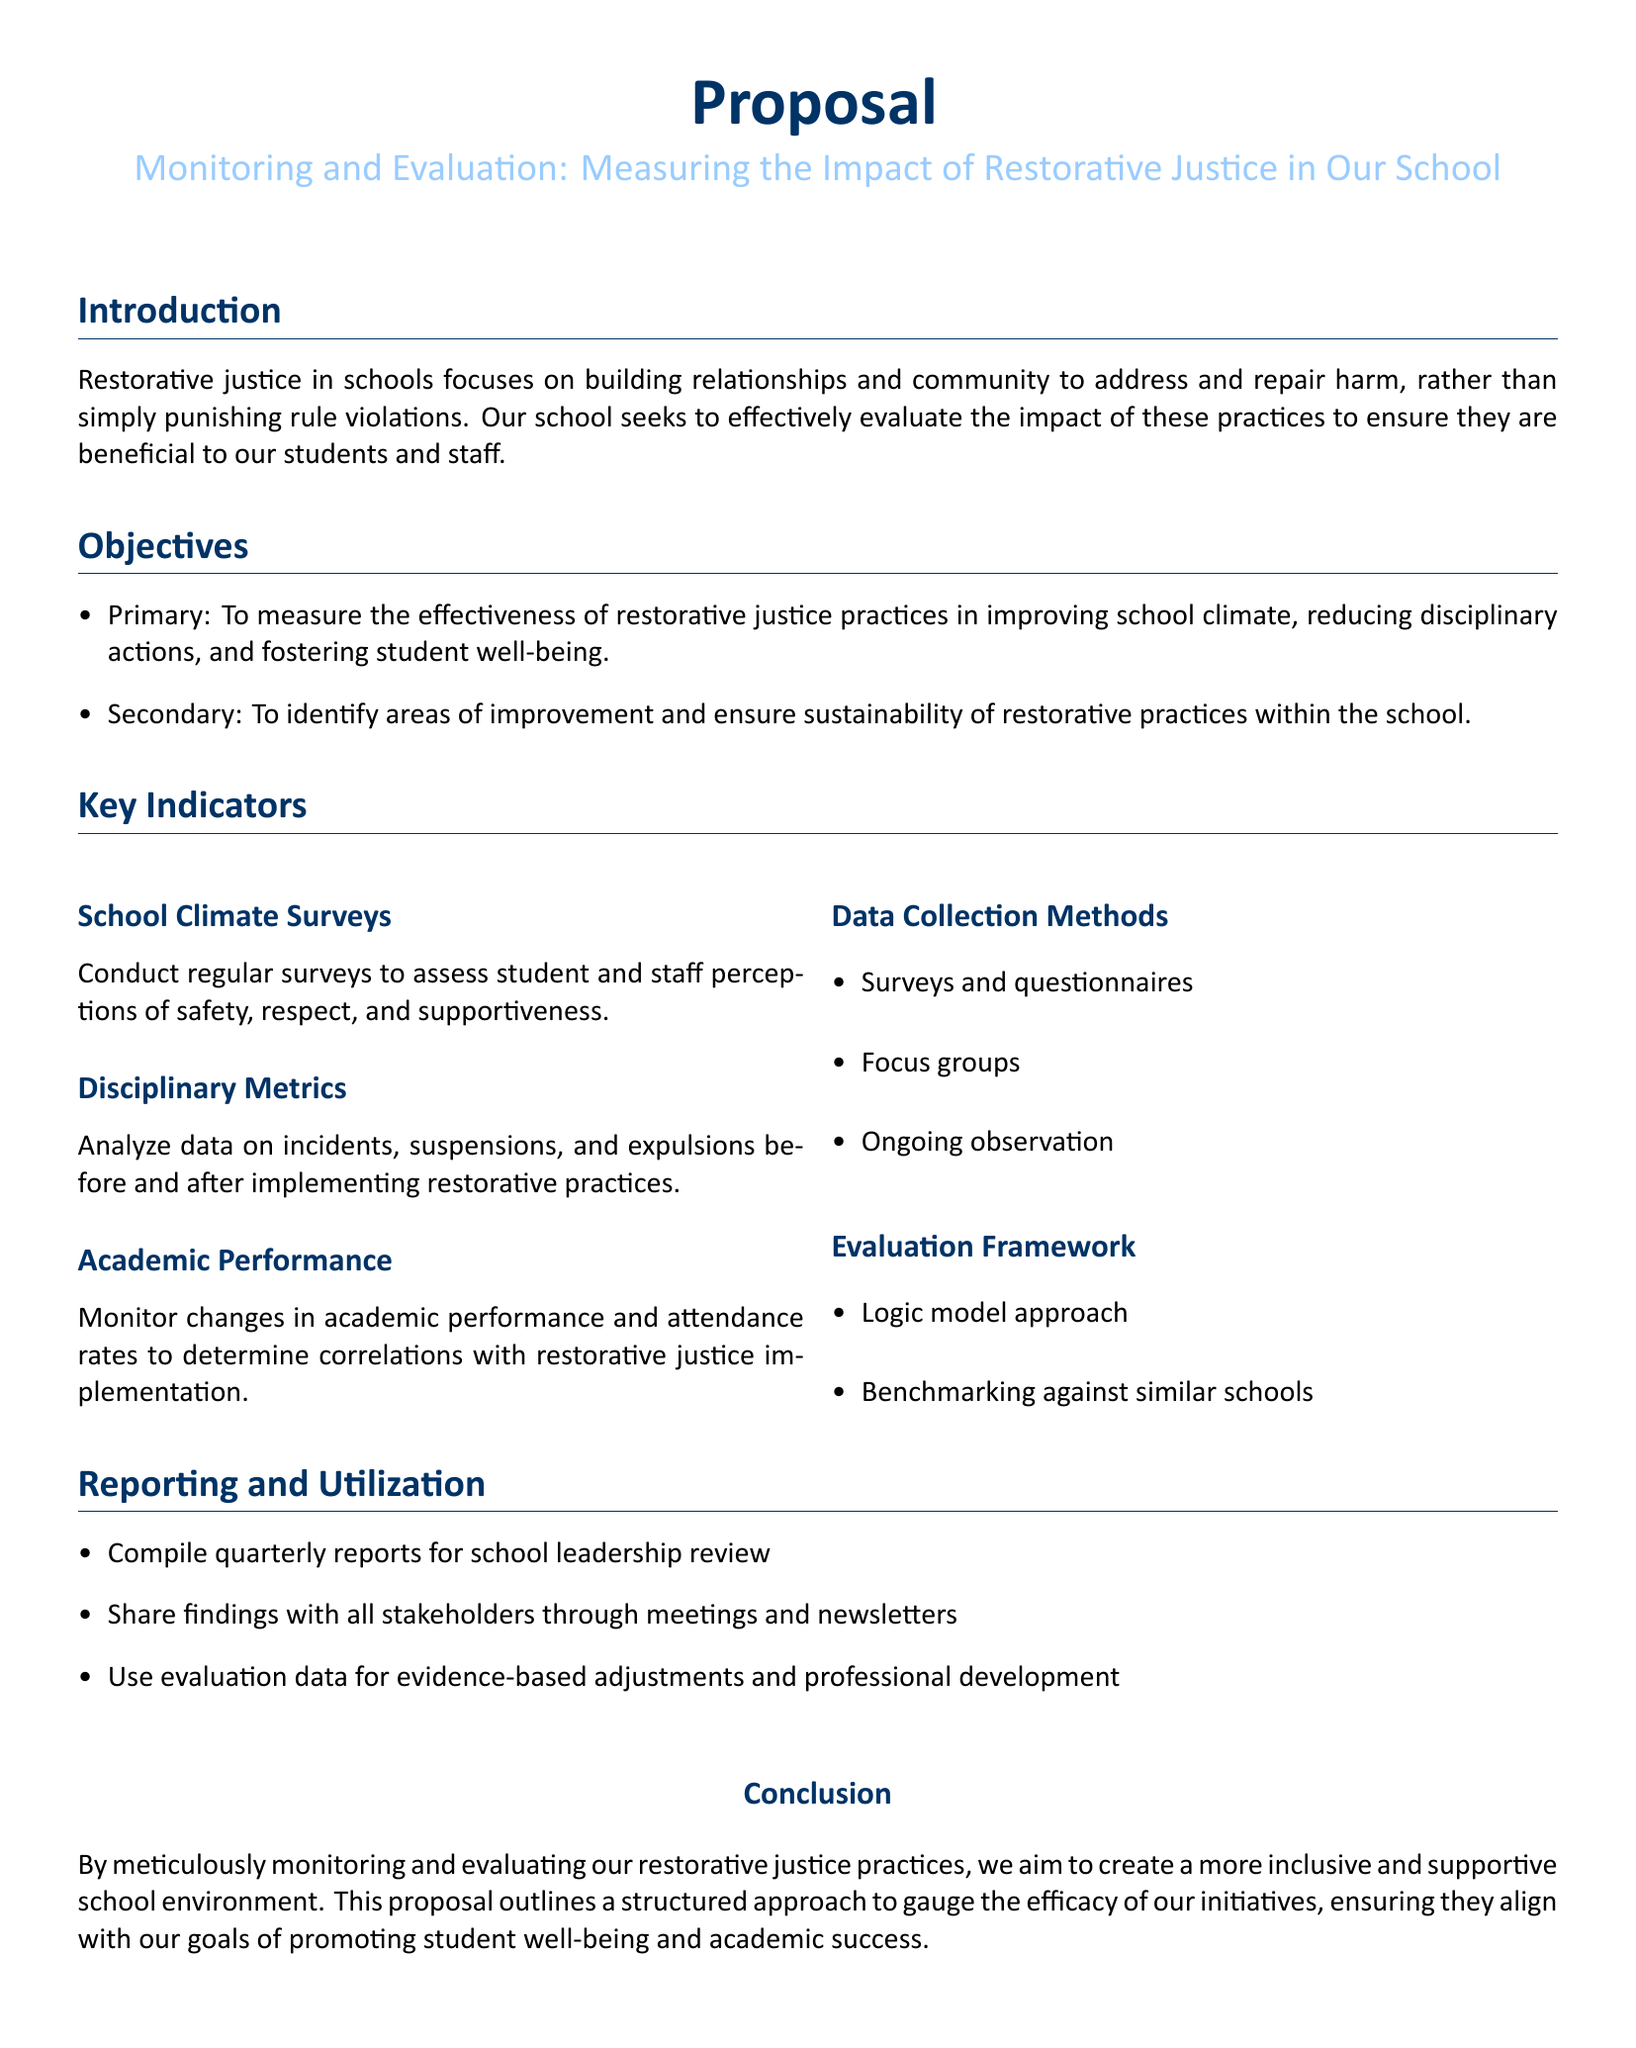What is the primary objective of the proposal? The primary objective is to measure the effectiveness of restorative justice practices in improving school climate, reducing disciplinary actions, and fostering student well-being.
Answer: To measure the effectiveness of restorative justice practices in improving school climate, reducing disciplinary actions, and fostering student well-being What type of data collection methods are mentioned? The document lists specific data collection methods under the Key Indicators section.
Answer: Surveys and questionnaires, focus groups, ongoing observation How often will reports be compiled? The reporting frequency is specified in the Reporting and Utilization section, providing clarity on the schedule.
Answer: Quarterly What is one method to analyze disciplinary metrics? The method involves analyzing data on incidents, suspensions, and expulsions before and after implementing restorative practices.
Answer: Data on incidents, suspensions, and expulsions before and after implementing restorative practices What approach will be used for the evaluation framework? The proposal mentions a specific approach to be taken for evaluating the restorative justice practices.
Answer: Logic model approach What are stakeholders expected to do with the evaluation findings? The proposal details what will be done with the compiled findings in the Reporting and Utilization section.
Answer: Share findings with all stakeholders through meetings and newsletters What is the main color used in the proposal's title? The color is specified in the document for visual distinction.
Answer: RGB(0,51,102) What is the overall goal of implementing restorative justice practices? The conclusion section summarizes the ultimate aim of these practices in the school environment.
Answer: To create a more inclusive and supportive school environment 